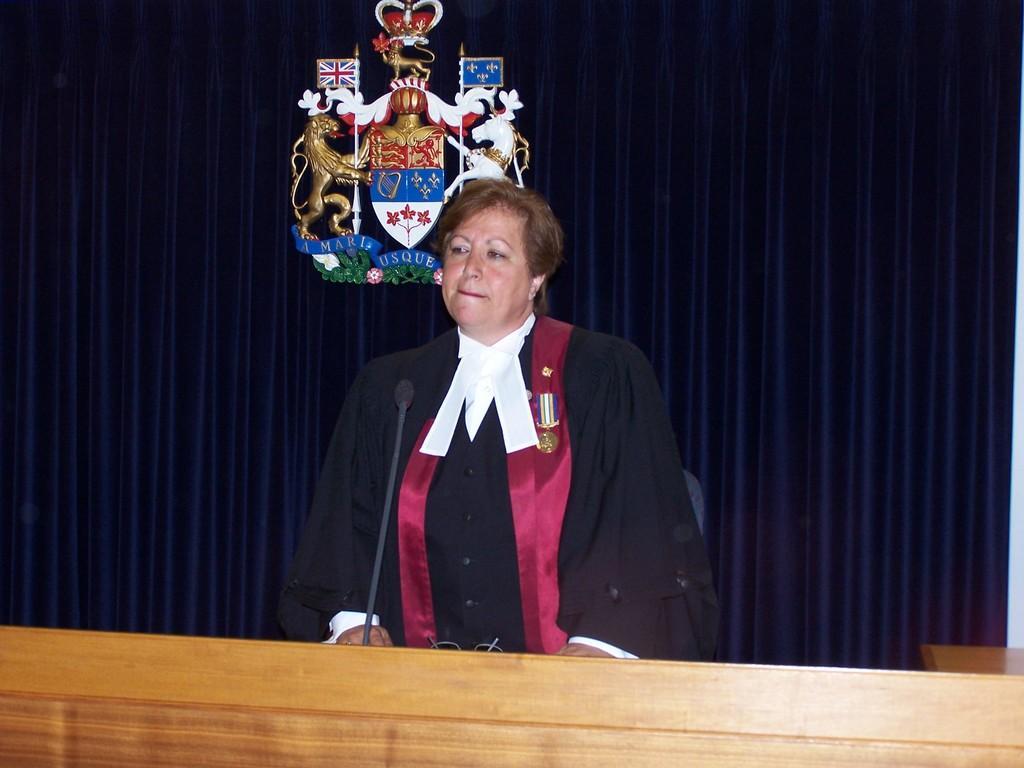Can you describe this image briefly? There is a person standing,in front of this person we can see microphone and spectacle on the table. Background we can see curtain,animal statues and flags. 